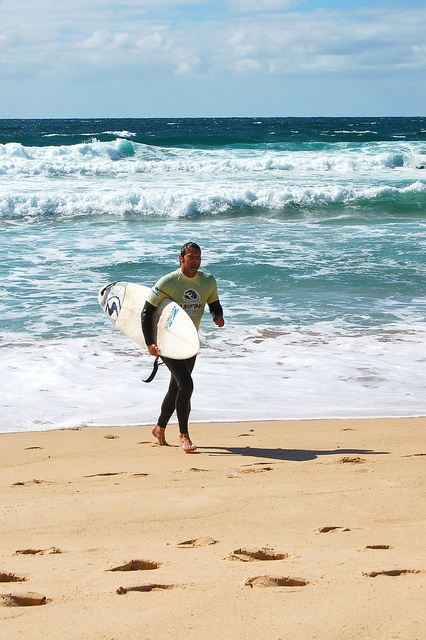Describe the objects in this image and their specific colors. I can see people in darkgray, black, olive, gray, and maroon tones and surfboard in darkgray, ivory, gray, and tan tones in this image. 